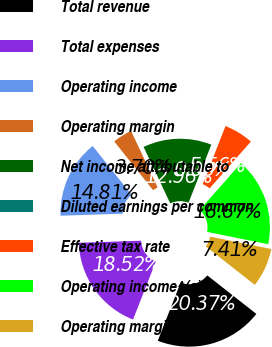<chart> <loc_0><loc_0><loc_500><loc_500><pie_chart><fcel>Total revenue<fcel>Total expenses<fcel>Operating income<fcel>Operating margin<fcel>Net income attributable to<fcel>Diluted earnings per common<fcel>Effective tax rate<fcel>Operating income^(a)<fcel>Operating margin^(a)<nl><fcel>20.37%<fcel>18.52%<fcel>14.81%<fcel>3.7%<fcel>12.96%<fcel>0.0%<fcel>5.56%<fcel>16.67%<fcel>7.41%<nl></chart> 